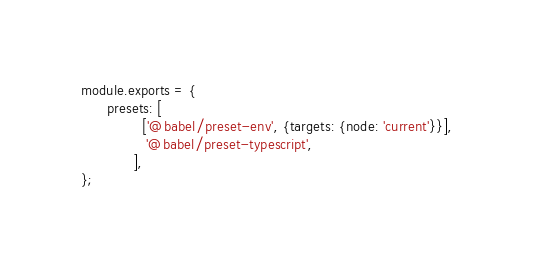<code> <loc_0><loc_0><loc_500><loc_500><_JavaScript_>module.exports = {
      presets: [
              ['@babel/preset-env', {targets: {node: 'current'}}],
               '@babel/preset-typescript',
            ],
};
</code> 